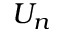Convert formula to latex. <formula><loc_0><loc_0><loc_500><loc_500>U _ { n }</formula> 